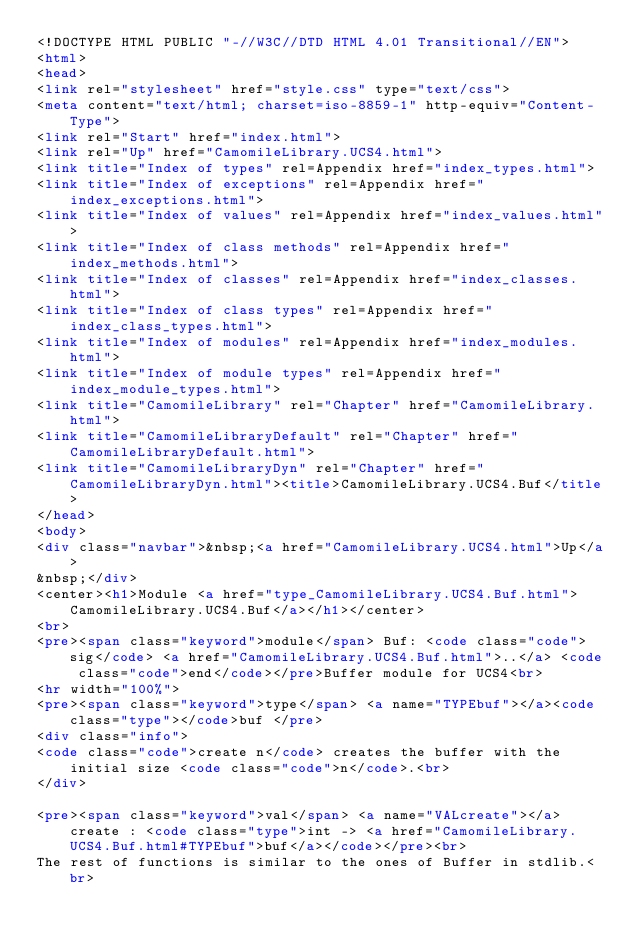Convert code to text. <code><loc_0><loc_0><loc_500><loc_500><_HTML_><!DOCTYPE HTML PUBLIC "-//W3C//DTD HTML 4.01 Transitional//EN">
<html>
<head>
<link rel="stylesheet" href="style.css" type="text/css">
<meta content="text/html; charset=iso-8859-1" http-equiv="Content-Type">
<link rel="Start" href="index.html">
<link rel="Up" href="CamomileLibrary.UCS4.html">
<link title="Index of types" rel=Appendix href="index_types.html">
<link title="Index of exceptions" rel=Appendix href="index_exceptions.html">
<link title="Index of values" rel=Appendix href="index_values.html">
<link title="Index of class methods" rel=Appendix href="index_methods.html">
<link title="Index of classes" rel=Appendix href="index_classes.html">
<link title="Index of class types" rel=Appendix href="index_class_types.html">
<link title="Index of modules" rel=Appendix href="index_modules.html">
<link title="Index of module types" rel=Appendix href="index_module_types.html">
<link title="CamomileLibrary" rel="Chapter" href="CamomileLibrary.html">
<link title="CamomileLibraryDefault" rel="Chapter" href="CamomileLibraryDefault.html">
<link title="CamomileLibraryDyn" rel="Chapter" href="CamomileLibraryDyn.html"><title>CamomileLibrary.UCS4.Buf</title>
</head>
<body>
<div class="navbar">&nbsp;<a href="CamomileLibrary.UCS4.html">Up</a>
&nbsp;</div>
<center><h1>Module <a href="type_CamomileLibrary.UCS4.Buf.html">CamomileLibrary.UCS4.Buf</a></h1></center>
<br>
<pre><span class="keyword">module</span> Buf: <code class="code">sig</code> <a href="CamomileLibrary.UCS4.Buf.html">..</a> <code class="code">end</code></pre>Buffer module for UCS4<br>
<hr width="100%">
<pre><span class="keyword">type</span> <a name="TYPEbuf"></a><code class="type"></code>buf </pre>
<div class="info">
<code class="code">create n</code> creates the buffer with the initial size <code class="code">n</code>.<br>
</div>

<pre><span class="keyword">val</span> <a name="VALcreate"></a>create : <code class="type">int -> <a href="CamomileLibrary.UCS4.Buf.html#TYPEbuf">buf</a></code></pre><br>
The rest of functions is similar to the ones of Buffer in stdlib.<br></code> 